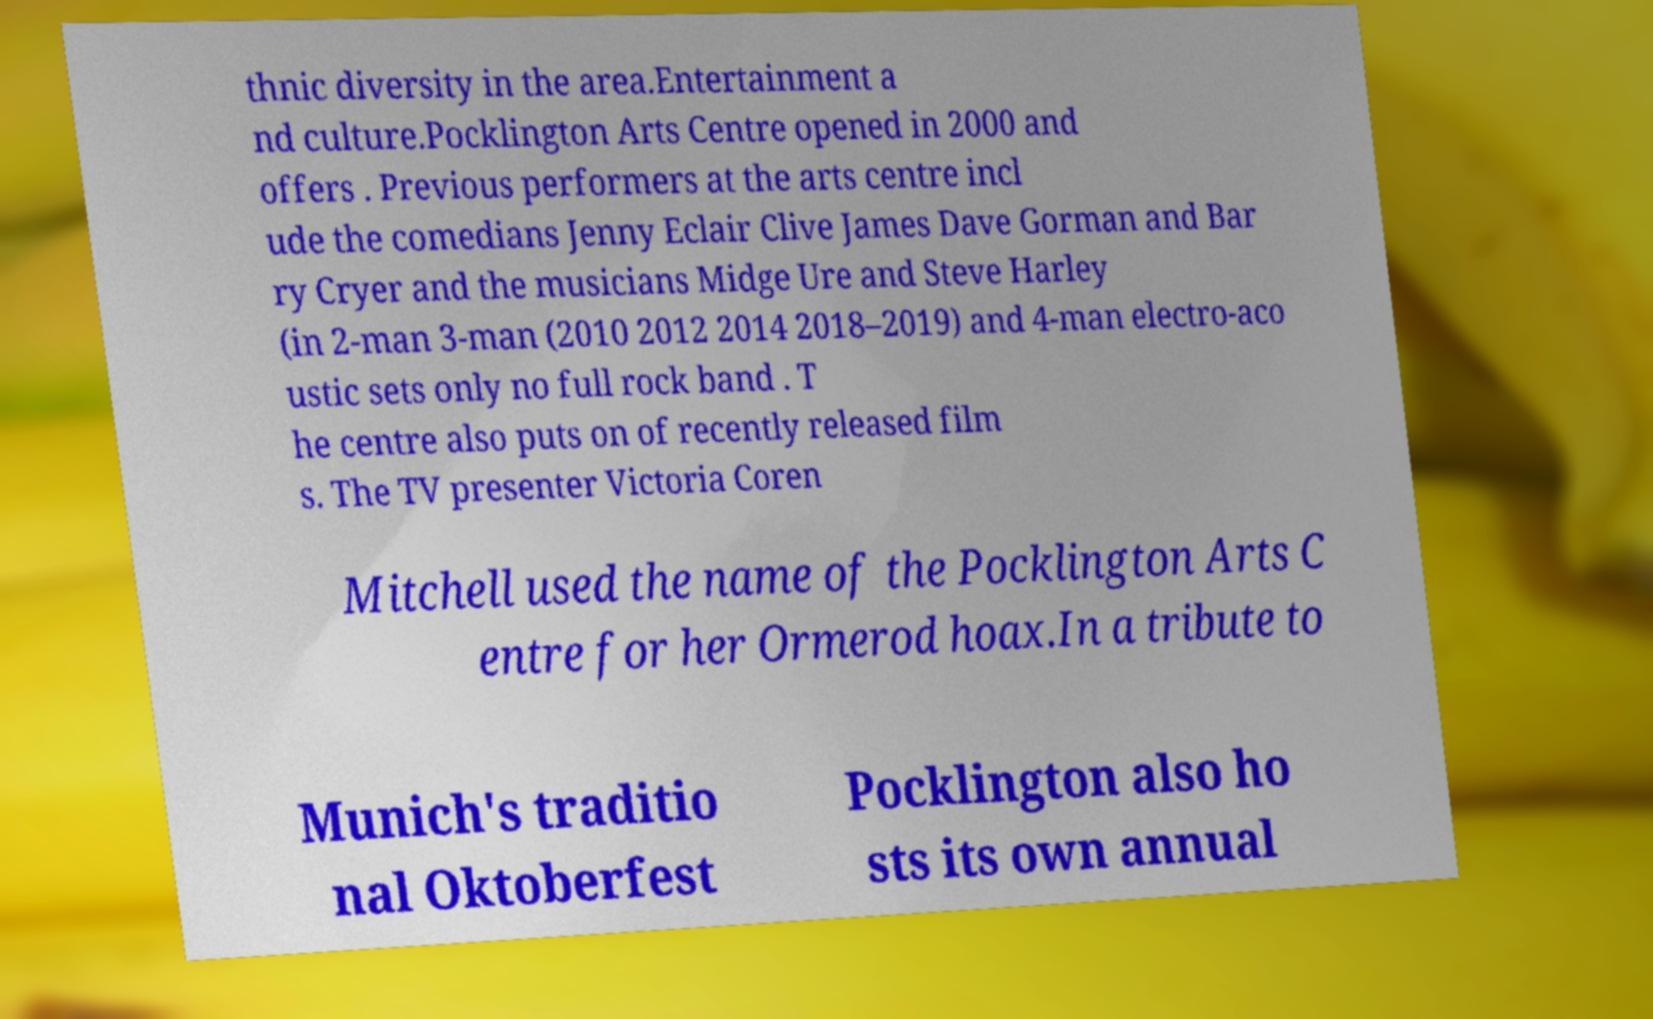Could you extract and type out the text from this image? thnic diversity in the area.Entertainment a nd culture.Pocklington Arts Centre opened in 2000 and offers . Previous performers at the arts centre incl ude the comedians Jenny Eclair Clive James Dave Gorman and Bar ry Cryer and the musicians Midge Ure and Steve Harley (in 2-man 3-man (2010 2012 2014 2018–2019) and 4-man electro-aco ustic sets only no full rock band . T he centre also puts on of recently released film s. The TV presenter Victoria Coren Mitchell used the name of the Pocklington Arts C entre for her Ormerod hoax.In a tribute to Munich's traditio nal Oktoberfest Pocklington also ho sts its own annual 